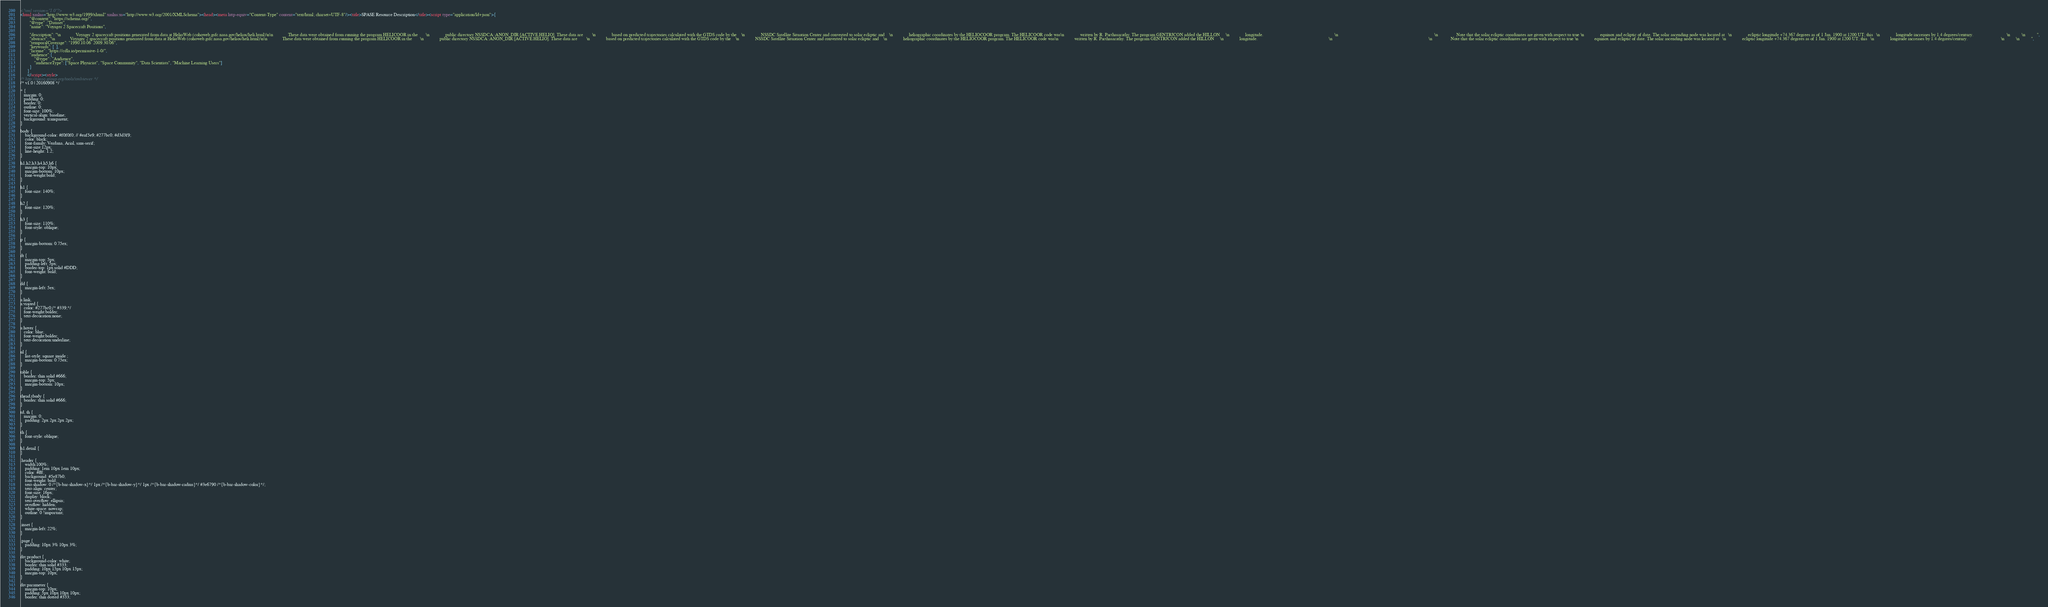<code> <loc_0><loc_0><loc_500><loc_500><_HTML_><?xml version="1.0"?>
<html xmlns="http://www.w3.org/1999/xhtml" xmlns:xs="http://www.w3.org/2001/XMLSchema"><head><meta http-equiv="Content-Type" content="text/html; charset=UTF-8"/><title>SPASE Resource Description</title><script type="application/ld+json">{
		"@context": "https://schema.org/",
		"@type" :"Dataset",
		"name": "Voyager 2 Spacecraft Positions",
     
 		"description": "\n				Voyager 2 spacecraft positions generated from data at HelioWeb (cohoweb.gsfc.nasa.gov/helios/heli.html)\n\n				These data were obtained from running the program HELICOOR in the       \n				public directory NSSDCA::ANON_DIR:[ACTIVE.HELIO]. These data are        \n				based on predicted trajectories calculated with the GTDS code by the    \n				NSSDC Satellite Situation Center and converted to solar ecliptic and    \n				heliographic coordinates by the HELIOCOOR program. The HELICOOR code was\n				written by R. Parthasarathy. The program GENTRJCON added the HILLON     \n				longitude.                                                              \n																					  \n				Note that the solar ecliptic coordinates are given with respect to true \n				equinox and ecliptic of date. The solar ascending node was located at   \n				ecliptic longitude +74.367 degrees as of 1 Jan. 1900 at 1200 UT; this   \n				longitude increases by 1.4 degrees/century.                             \n			\n			",
		"abstract": "\n				Voyager 2 spacecraft positions generated from data at HelioWeb (cohoweb.gsfc.nasa.gov/helios/heli.html)\n\n				These data were obtained from running the program HELICOOR in the       \n				public directory NSSDCA::ANON_DIR:[ACTIVE.HELIO]. These data are        \n				based on predicted trajectories calculated with the GTDS code by the    \n				NSSDC Satellite Situation Center and converted to solar ecliptic and    \n				heliographic coordinates by the HELIOCOOR program. The HELICOOR code was\n				written by R. Parthasarathy. The program GENTRJCON added the HILLON     \n				longitude.                                                              \n																					  \n				Note that the solar ecliptic coordinates are given with respect to true \n				equinox and ecliptic of date. The solar ascending node was located at   \n				ecliptic longitude +74.367 degrees as of 1 Jan. 1900 at 1200 UT; this   \n				longitude increases by 1.4 degrees/century.                             \n			\n			",
		"temporalCoverage": "1990.10.06  2009.30.06",
		"keywords": [  ],
		"license": "https://cdla.io/permissive-1-0/",
        "audience":{
            "@type": "Audience",
            "audienceType": ["Space Physicist", "Space Community", "Data Scientists", "Machine Learning Users"]
        }
	  }
	  </script><style>
/* http://spase-group.org/tools/xmlviewer */
/* v1.0 | 20160908 */

* {
   margin: 0;
   padding: 0;
   border: 0;
   outline: 0;
   font-size: 100%;
   vertical-align: baseline;
   background: transparent;
}

body {
	background-color: #f0f0f0; // #eaf5e9; #277bc0; #d3d3f9;
	color: black;
	font-family: Verdana, Arial, sans-serif; 
	font-size:12px; 
	line-height: 1.2;
}
 
h1,h2,h3,h4,h5,h6 {
	margin-top: 10px;
	margin-bottom: 10px;
	font-weight:bold;
}

h1 {
	font-size: 140%;
}

h2 {
	font-size: 120%;
}

h3 {
	font-size: 110%;
	font-style: oblique;
}

p {
	margin-bottom: 0.75ex;
}

dt {
	margin-top: 5px;
	padding-left: 5px;
	border-top: 1px solid #DDD;
	font-weight: bold;
}

dd {
	margin-left: 5ex;
}

a:link,
a:visited {
   color: #277bc0;/* #339;*/
   font-weight:bolder; 
   text-decoration:none; 
}

a:hover {
   color: blue;
   font-weight:bolder; 
   text-decoration:underline; 
}

ul {
	list-style: square inside ;
	margin-bottom: 0.75ex;
}

table {
   border: thin solid #666;
	margin-top: 5px;
	margin-bottom: 10px;
}

thead,tbody {
   border: thin solid #666;
}

td, th {
   margin: 0;
	padding: 2px 2px 2px 2px;
}

th {
	font-style: oblique;
}

h1.detail {
}

.header {
	width:100%;
	padding: 1em 10px 1em 10px;
	color: #fff;
	background: #5e87b0;
	font-weight: bold;
	text-shadow: 0 /*{b-bar-shadow-x}*/ 1px /*{b-bar-shadow-y}*/ 1px /*{b-bar-shadow-radius}*/ #3e6790 /*{b-bar-shadow-color}*/;
	text-align: center;
	font-size: 16px;
	display: block;
	text-overflow: ellipsis;
	overflow: hidden;
	white-space: nowrap;
	outline: 0 !important;
}

.inset {
	margin-left: 22%;
}

.page {
	padding: 10px 3% 10px 3%;
}

div.product {
	background-color: white;
	border: thin solid #333;
	padding: 10px 15px 10px 15px;
	margin-top: 10px;
}

div.parameter {
	margin-top: 10px;
	padding: 5px 10px 10px 10px;
	border: thin dotted #333;</code> 